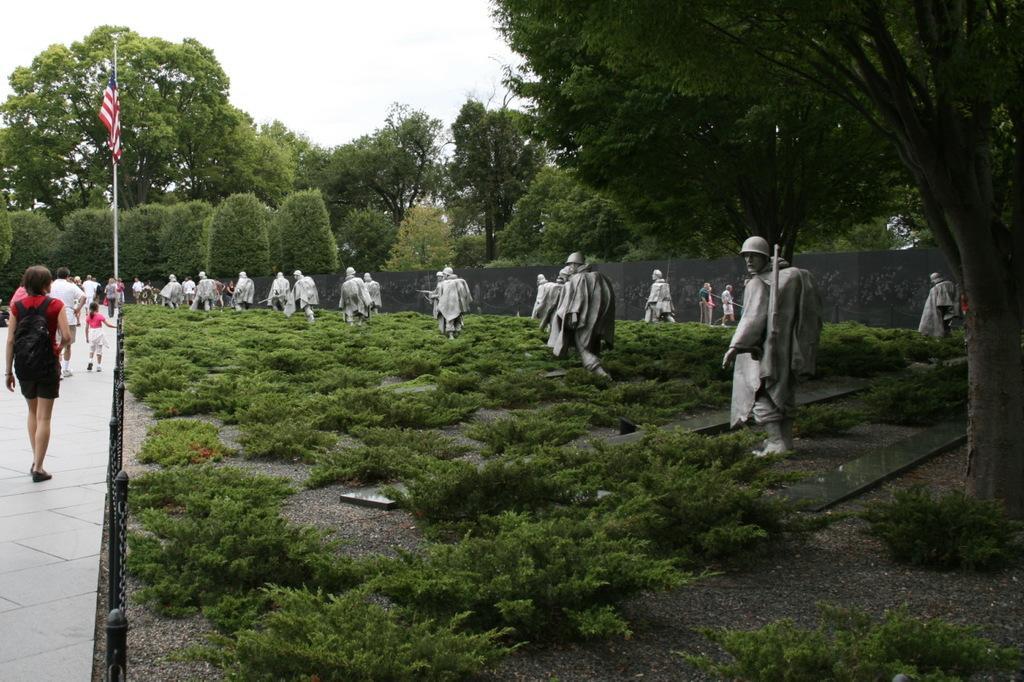Describe this image in one or two sentences. In this picture we can see few statues, plants and trees, and we can find group of people they are walking, beside to them we can find few metal rods and a flag. 